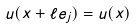<formula> <loc_0><loc_0><loc_500><loc_500>u ( x + \ell e _ { j } ) = u ( x )</formula> 